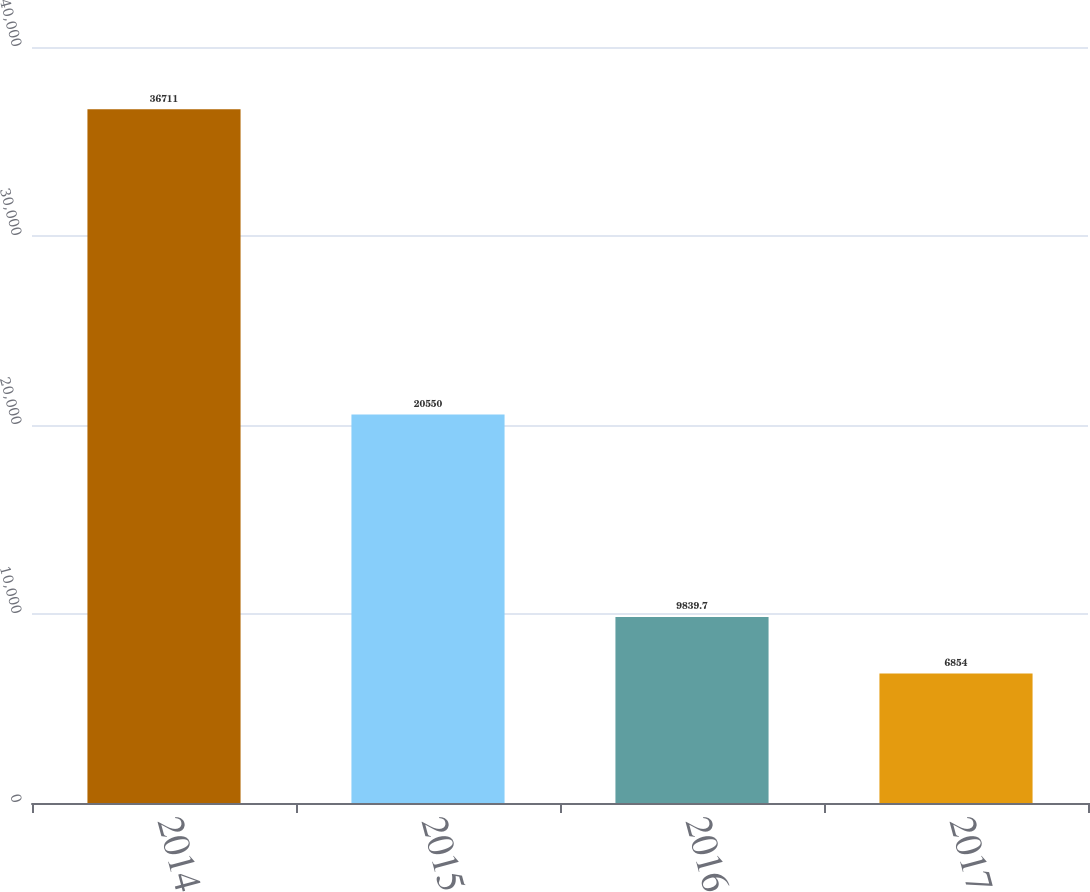<chart> <loc_0><loc_0><loc_500><loc_500><bar_chart><fcel>2014<fcel>2015<fcel>2016<fcel>2017<nl><fcel>36711<fcel>20550<fcel>9839.7<fcel>6854<nl></chart> 